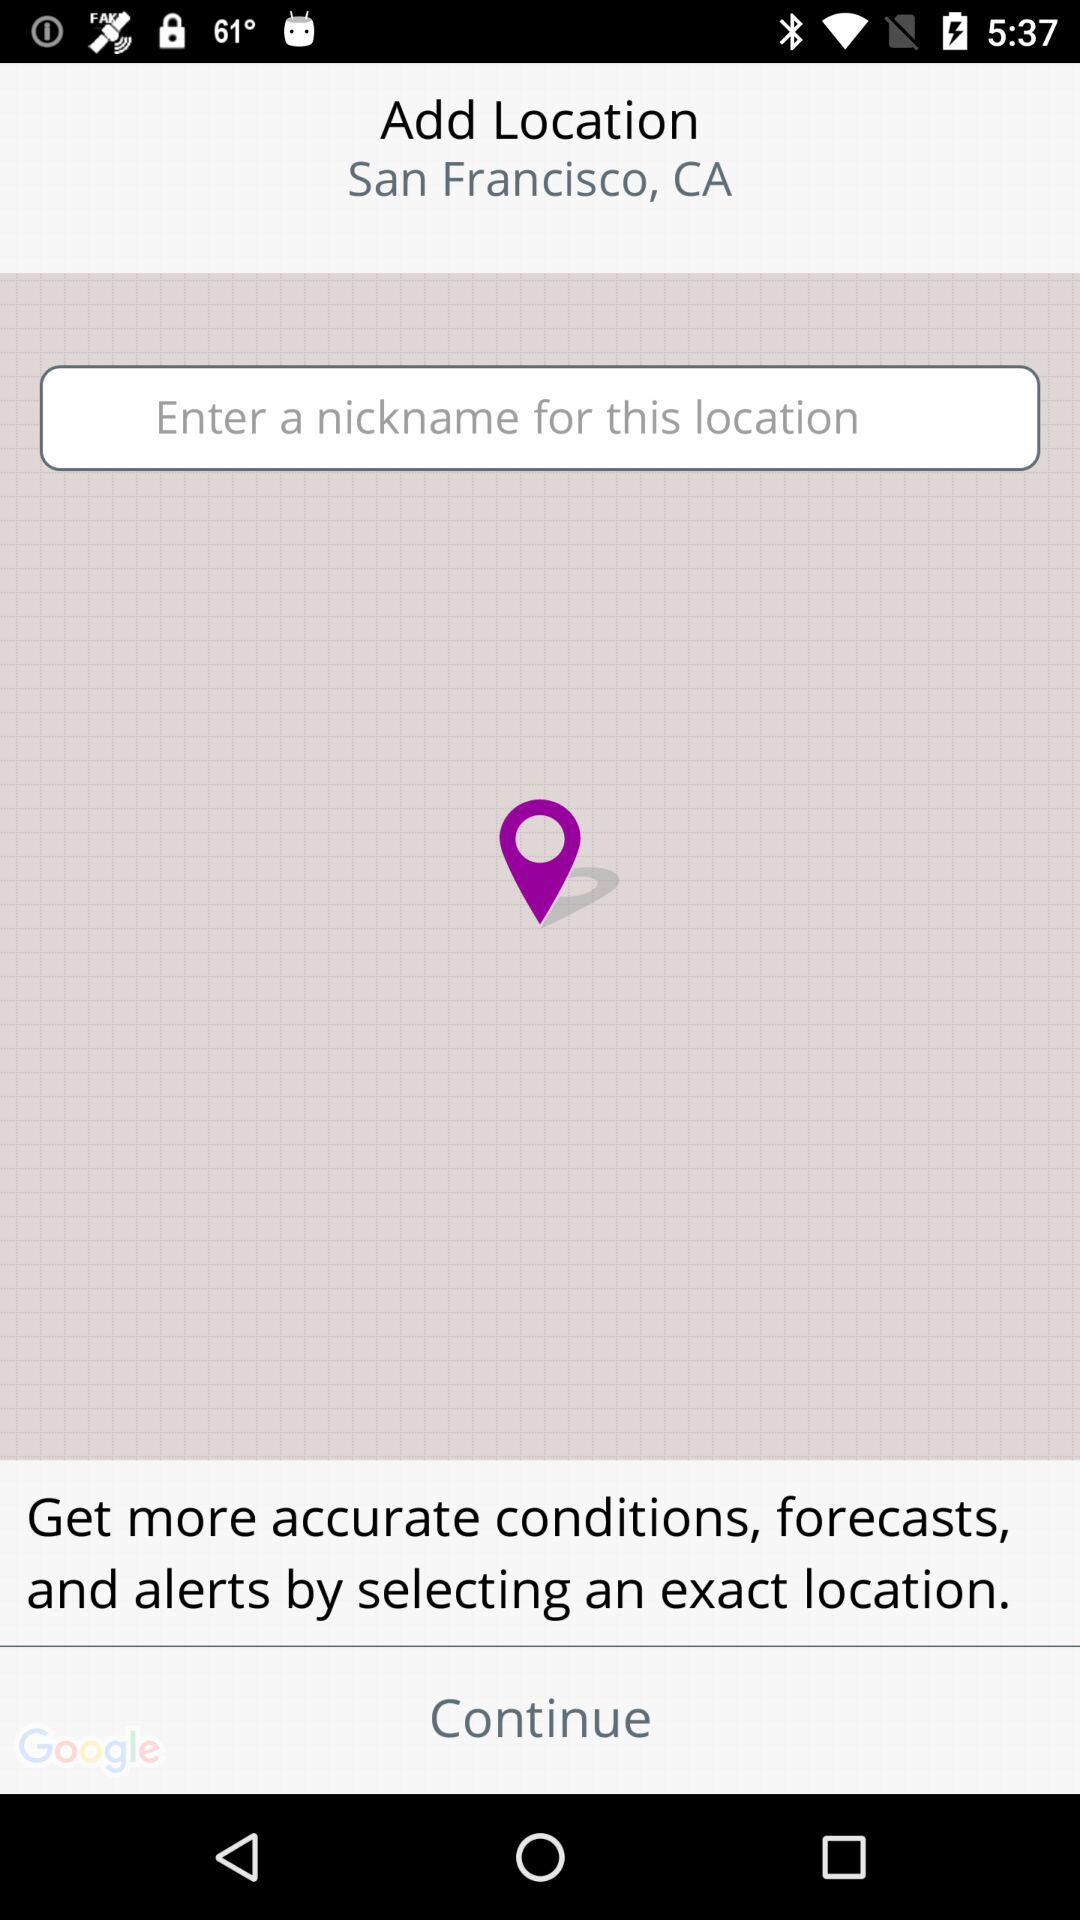What is the entered nickname?
When the provided information is insufficient, respond with <no answer>. <no answer> 